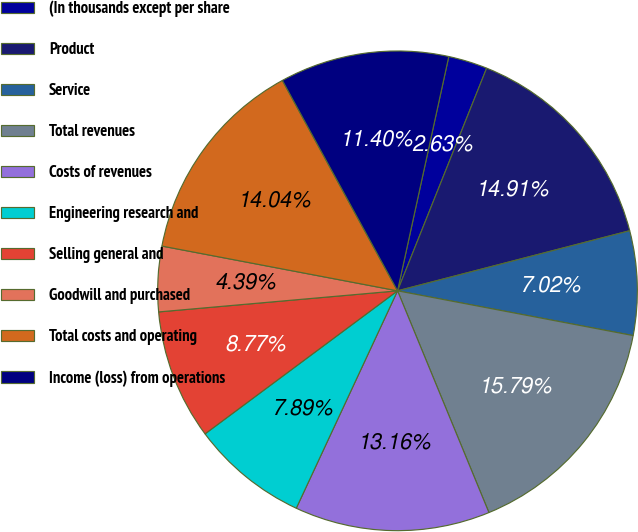Convert chart to OTSL. <chart><loc_0><loc_0><loc_500><loc_500><pie_chart><fcel>(In thousands except per share<fcel>Product<fcel>Service<fcel>Total revenues<fcel>Costs of revenues<fcel>Engineering research and<fcel>Selling general and<fcel>Goodwill and purchased<fcel>Total costs and operating<fcel>Income (loss) from operations<nl><fcel>2.63%<fcel>14.91%<fcel>7.02%<fcel>15.79%<fcel>13.16%<fcel>7.89%<fcel>8.77%<fcel>4.39%<fcel>14.04%<fcel>11.4%<nl></chart> 